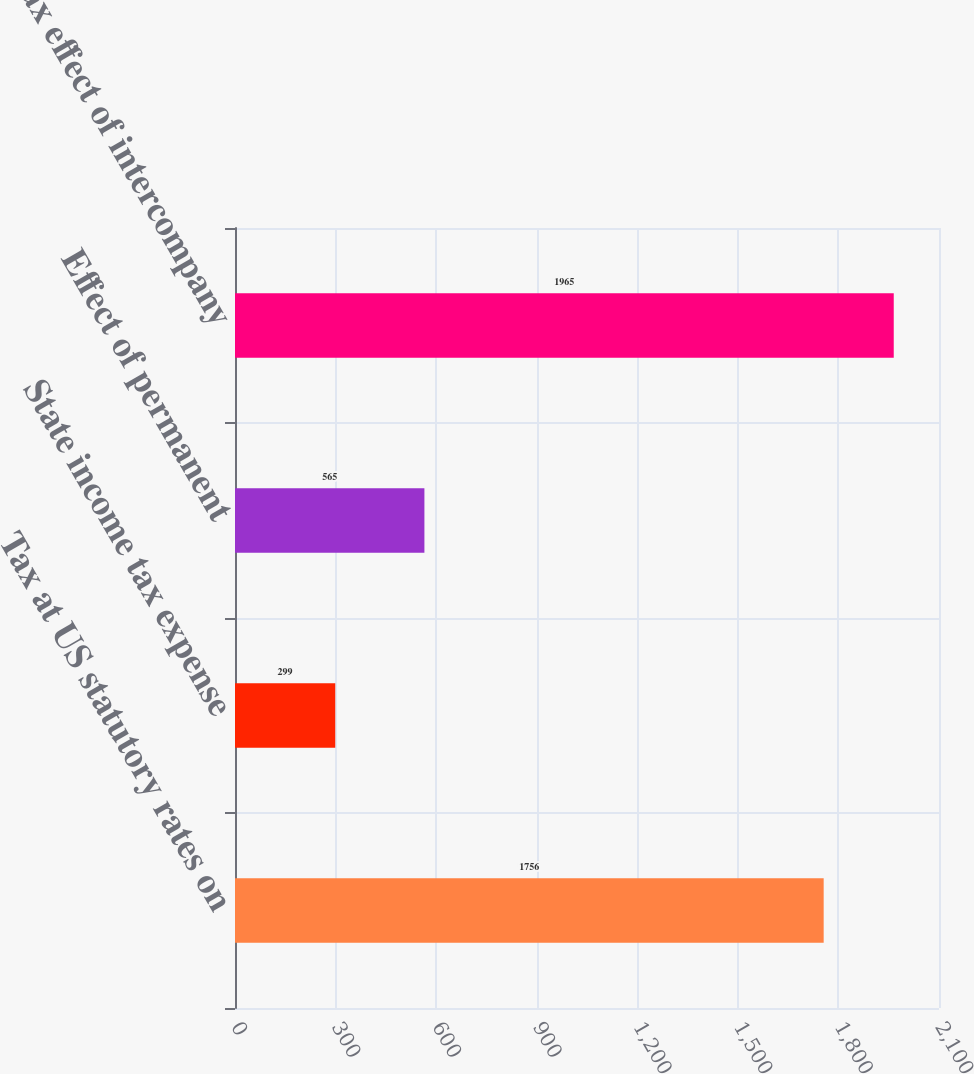Convert chart to OTSL. <chart><loc_0><loc_0><loc_500><loc_500><bar_chart><fcel>Tax at US statutory rates on<fcel>State income tax expense<fcel>Effect of permanent<fcel>Tax effect of intercompany<nl><fcel>1756<fcel>299<fcel>565<fcel>1965<nl></chart> 